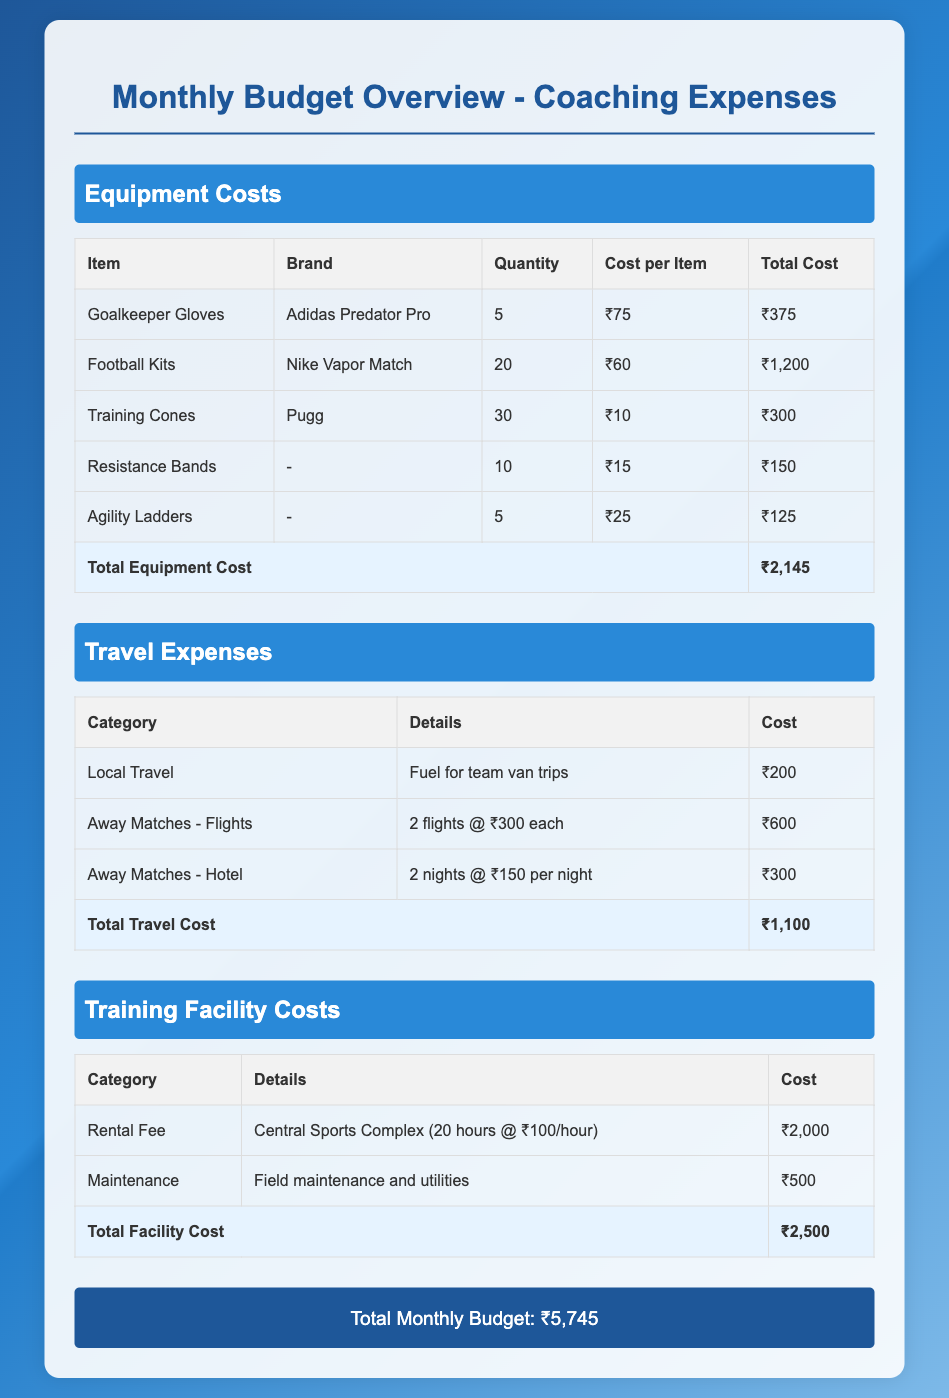What is the total equipment cost? The total equipment cost is listed at the bottom of the equipment section, summing up all individual equipment costs.
Answer: ₹2,145 How many goalkeeper gloves were purchased? The quantity of goalkeeper gloves is detailed in the equipment table, specifically mentioned in the row for goalkeeper gloves.
Answer: 5 What is the cost for the hotel during away matches? The cost for the hotel is specified in the travel expenses section under the "Away Matches - Hotel" category.
Answer: ₹300 What is the rental fee for the training facility? The rental fee is mentioned in the training facility costs section, specifically in the row for the rental fee.
Answer: ₹2,000 What brand of football kits were bought? The brand of football kits is specified in the equipment table next to the item "Football Kits."
Answer: Nike Vapor Match What is the total monthly budget? The total monthly budget is summarized at the bottom of the document in the grand total section, representing the sum of all expenses.
Answer: ₹5,745 How many training cones were purchased? The quantity for training cones is listed in the equipment section, specifically in the row for training cones.
Answer: 30 What is the total travel cost? The total travel cost is shown clearly at the end of the travel expenses section, summing up all travel-related costs.
Answer: ₹1,100 What are the details for the maintenance of the training facility? The details for maintenance are described in the training facility costs section, detailing its purpose.
Answer: Field maintenance and utilities 